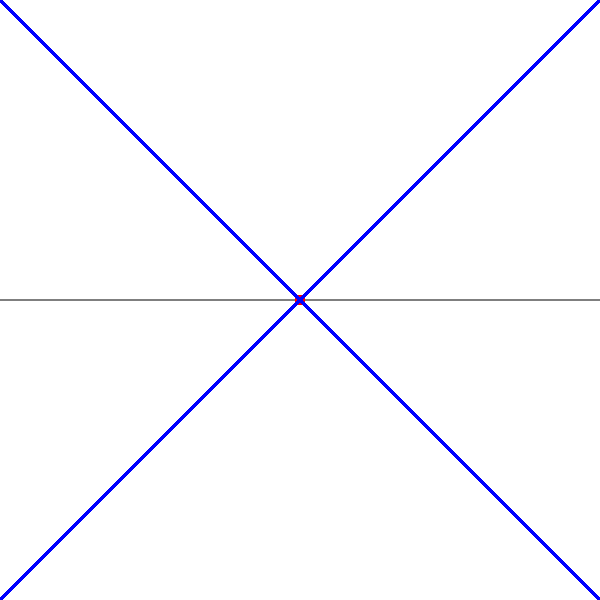In anime-inspired digital artwork, how does using a single vanishing point affect the perception of depth in a scene, and what are the key elements to consider when setting up a perspective grid for this technique? 1. Single Vanishing Point Perspective:
   - All parallel lines converge to a single point on the horizon line.
   - Creates a sense of depth and distance in the artwork.

2. Horizon Line:
   - Represents the viewer's eye level.
   - Typically placed at about 1/3 from the bottom or top of the composition for a balanced look.

3. Vanishing Point:
   - Located on the horizon line.
   - All receding parallel lines converge at this point.

4. Perspective Grid:
   - Consists of lines radiating from the vanishing point.
   - Helps in accurately placing objects and characters in the scene.

5. Scale and Proportion:
   - Objects closer to the viewer appear larger.
   - Objects farther away appear smaller and converge towards the vanishing point.

6. Vertical Lines:
   - Remain vertical in single-point perspective.
   - Do not converge towards the vanishing point.

7. Depth Cues:
   - Overlapping objects create a sense of depth.
   - Use of atmospheric perspective (less detail and contrast in distant objects) enhances depth perception.

8. Application in Anime-style Art:
   - Useful for interior scenes, hallways, or street views.
   - Can create dramatic and dynamic compositions.
   - Simplifies complex environments while maintaining a sense of space.

9. Digital Tools:
   - Use layers to separate perspective grid from artwork.
   - Utilize digital rulers and guides for precise line placement.

10. Practice and Observation:
    - Study real-world environments and photographs to understand how perspective works in various scenarios.
    - Experiment with different vanishing point placements for diverse effects.
Answer: Single vanishing point creates depth by converging parallel lines to one point on the horizon. Key elements: horizon line, vanishing point, perspective grid, scale, and vertical lines. 